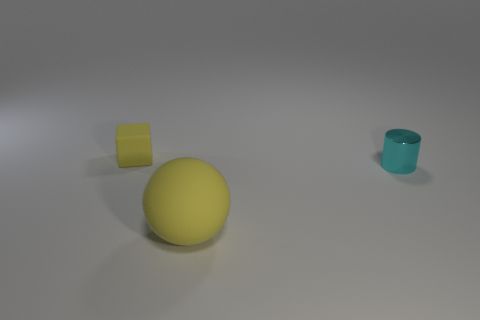Add 3 large purple rubber cubes. How many objects exist? 6 Subtract all large rubber objects. Subtract all big balls. How many objects are left? 1 Add 3 cylinders. How many cylinders are left? 4 Add 3 small yellow things. How many small yellow things exist? 4 Subtract 0 cyan spheres. How many objects are left? 3 Subtract all blocks. How many objects are left? 2 Subtract 1 balls. How many balls are left? 0 Subtract all red cylinders. Subtract all red cubes. How many cylinders are left? 1 